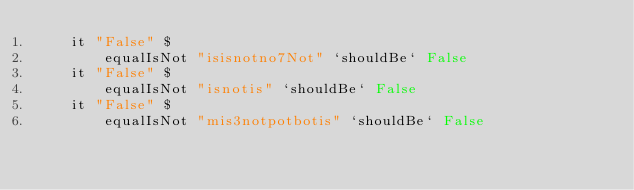Convert code to text. <code><loc_0><loc_0><loc_500><loc_500><_Haskell_>    it "False" $
        equalIsNot "isisnotno7Not" `shouldBe` False
    it "False" $
        equalIsNot "isnotis" `shouldBe` False
    it "False" $
        equalIsNot "mis3notpotbotis" `shouldBe` False
</code> 